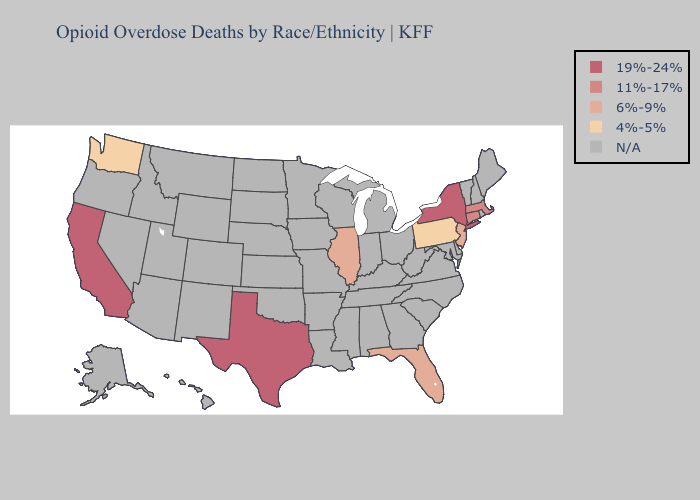Is the legend a continuous bar?
Keep it brief. No. Does New Jersey have the highest value in the Northeast?
Give a very brief answer. No. Which states have the highest value in the USA?
Answer briefly. California, New York, Texas. Name the states that have a value in the range 6%-9%?
Be succinct. Florida, Illinois, New Jersey. What is the lowest value in the West?
Quick response, please. 4%-5%. Is the legend a continuous bar?
Quick response, please. No. Is the legend a continuous bar?
Quick response, please. No. Does the first symbol in the legend represent the smallest category?
Quick response, please. No. Among the states that border Delaware , which have the highest value?
Answer briefly. New Jersey. Does the first symbol in the legend represent the smallest category?
Write a very short answer. No. What is the lowest value in states that border New Mexico?
Quick response, please. 19%-24%. 